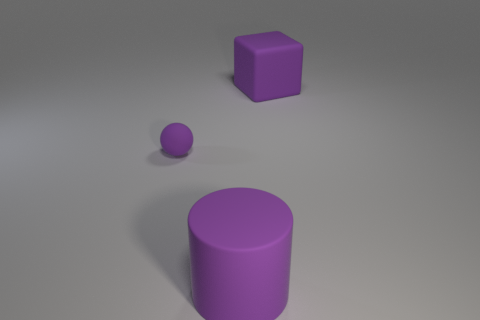Is there a small metallic block that has the same color as the tiny thing?
Your answer should be very brief. No. Is there a tiny blue rubber cube?
Offer a very short reply. No. How many small objects are either matte balls or purple rubber blocks?
Offer a terse response. 1. The large rubber cube is what color?
Ensure brevity in your answer.  Purple. The large matte object that is behind the purple object that is in front of the small purple object is what shape?
Keep it short and to the point. Cube. Are there any blue spheres made of the same material as the purple sphere?
Make the answer very short. No. There is a purple thing that is in front of the sphere; does it have the same size as the tiny purple ball?
Make the answer very short. No. How many green things are either rubber spheres or big rubber cylinders?
Offer a terse response. 0. What is the big thing that is in front of the block made of?
Give a very brief answer. Rubber. How many rubber things are to the right of the purple rubber object that is to the right of the big cylinder?
Provide a short and direct response. 0. 